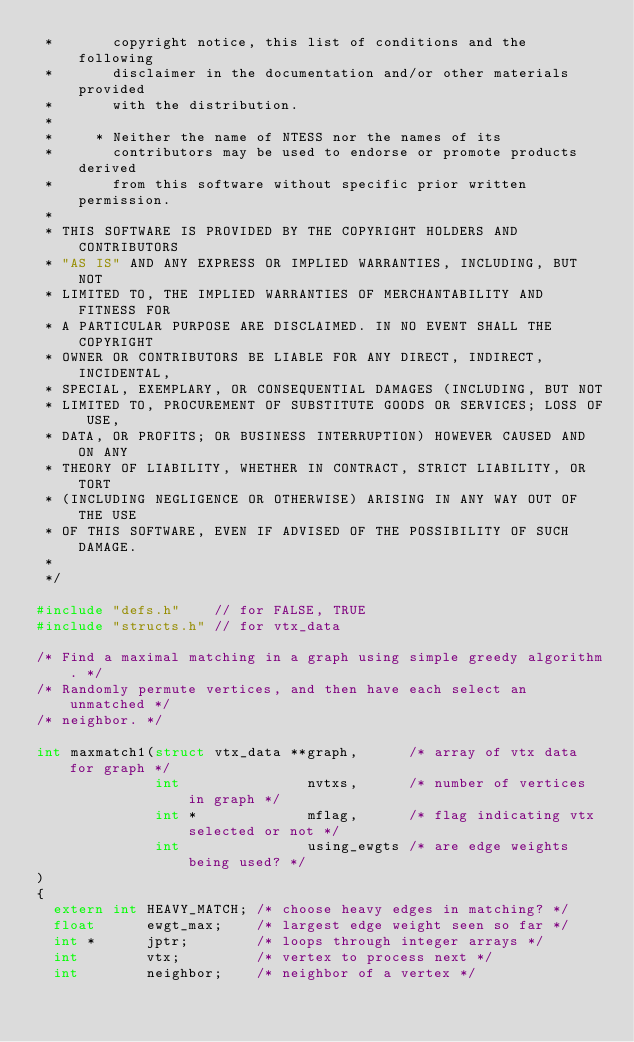Convert code to text. <code><loc_0><loc_0><loc_500><loc_500><_C_> *       copyright notice, this list of conditions and the following
 *       disclaimer in the documentation and/or other materials provided
 *       with the distribution.
 *
 *     * Neither the name of NTESS nor the names of its
 *       contributors may be used to endorse or promote products derived
 *       from this software without specific prior written permission.
 *
 * THIS SOFTWARE IS PROVIDED BY THE COPYRIGHT HOLDERS AND CONTRIBUTORS
 * "AS IS" AND ANY EXPRESS OR IMPLIED WARRANTIES, INCLUDING, BUT NOT
 * LIMITED TO, THE IMPLIED WARRANTIES OF MERCHANTABILITY AND FITNESS FOR
 * A PARTICULAR PURPOSE ARE DISCLAIMED. IN NO EVENT SHALL THE COPYRIGHT
 * OWNER OR CONTRIBUTORS BE LIABLE FOR ANY DIRECT, INDIRECT, INCIDENTAL,
 * SPECIAL, EXEMPLARY, OR CONSEQUENTIAL DAMAGES (INCLUDING, BUT NOT
 * LIMITED TO, PROCUREMENT OF SUBSTITUTE GOODS OR SERVICES; LOSS OF USE,
 * DATA, OR PROFITS; OR BUSINESS INTERRUPTION) HOWEVER CAUSED AND ON ANY
 * THEORY OF LIABILITY, WHETHER IN CONTRACT, STRICT LIABILITY, OR TORT
 * (INCLUDING NEGLIGENCE OR OTHERWISE) ARISING IN ANY WAY OUT OF THE USE
 * OF THIS SOFTWARE, EVEN IF ADVISED OF THE POSSIBILITY OF SUCH DAMAGE.
 *
 */

#include "defs.h"    // for FALSE, TRUE
#include "structs.h" // for vtx_data

/* Find a maximal matching in a graph using simple greedy algorithm. */
/* Randomly permute vertices, and then have each select an unmatched */
/* neighbor. */

int maxmatch1(struct vtx_data **graph,      /* array of vtx data for graph */
              int               nvtxs,      /* number of vertices in graph */
              int *             mflag,      /* flag indicating vtx selected or not */
              int               using_ewgts /* are edge weights being used? */
)
{
  extern int HEAVY_MATCH; /* choose heavy edges in matching? */
  float      ewgt_max;    /* largest edge weight seen so far */
  int *      jptr;        /* loops through integer arrays */
  int        vtx;         /* vertex to process next */
  int        neighbor;    /* neighbor of a vertex */</code> 